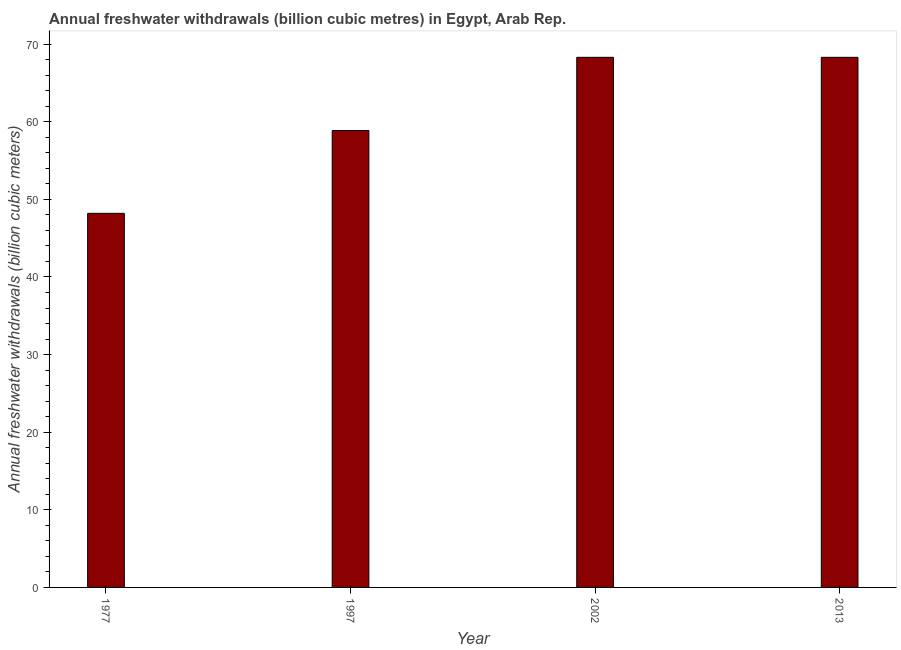Does the graph contain any zero values?
Ensure brevity in your answer.  No. Does the graph contain grids?
Give a very brief answer. No. What is the title of the graph?
Offer a very short reply. Annual freshwater withdrawals (billion cubic metres) in Egypt, Arab Rep. What is the label or title of the Y-axis?
Offer a very short reply. Annual freshwater withdrawals (billion cubic meters). What is the annual freshwater withdrawals in 1997?
Offer a terse response. 58.87. Across all years, what is the maximum annual freshwater withdrawals?
Offer a terse response. 68.3. Across all years, what is the minimum annual freshwater withdrawals?
Provide a short and direct response. 48.2. What is the sum of the annual freshwater withdrawals?
Your response must be concise. 243.67. What is the difference between the annual freshwater withdrawals in 1997 and 2013?
Your response must be concise. -9.43. What is the average annual freshwater withdrawals per year?
Offer a very short reply. 60.92. What is the median annual freshwater withdrawals?
Keep it short and to the point. 63.58. In how many years, is the annual freshwater withdrawals greater than 60 billion cubic meters?
Provide a succinct answer. 2. Do a majority of the years between 1977 and 1997 (inclusive) have annual freshwater withdrawals greater than 4 billion cubic meters?
Provide a succinct answer. Yes. What is the ratio of the annual freshwater withdrawals in 1977 to that in 1997?
Your response must be concise. 0.82. Is the difference between the annual freshwater withdrawals in 1977 and 2002 greater than the difference between any two years?
Keep it short and to the point. Yes. What is the difference between the highest and the lowest annual freshwater withdrawals?
Ensure brevity in your answer.  20.1. Are all the bars in the graph horizontal?
Provide a succinct answer. No. How many years are there in the graph?
Make the answer very short. 4. Are the values on the major ticks of Y-axis written in scientific E-notation?
Ensure brevity in your answer.  No. What is the Annual freshwater withdrawals (billion cubic meters) of 1977?
Your answer should be compact. 48.2. What is the Annual freshwater withdrawals (billion cubic meters) of 1997?
Provide a short and direct response. 58.87. What is the Annual freshwater withdrawals (billion cubic meters) in 2002?
Provide a short and direct response. 68.3. What is the Annual freshwater withdrawals (billion cubic meters) of 2013?
Your response must be concise. 68.3. What is the difference between the Annual freshwater withdrawals (billion cubic meters) in 1977 and 1997?
Keep it short and to the point. -10.67. What is the difference between the Annual freshwater withdrawals (billion cubic meters) in 1977 and 2002?
Offer a very short reply. -20.1. What is the difference between the Annual freshwater withdrawals (billion cubic meters) in 1977 and 2013?
Your answer should be compact. -20.1. What is the difference between the Annual freshwater withdrawals (billion cubic meters) in 1997 and 2002?
Give a very brief answer. -9.43. What is the difference between the Annual freshwater withdrawals (billion cubic meters) in 1997 and 2013?
Provide a short and direct response. -9.43. What is the ratio of the Annual freshwater withdrawals (billion cubic meters) in 1977 to that in 1997?
Your answer should be compact. 0.82. What is the ratio of the Annual freshwater withdrawals (billion cubic meters) in 1977 to that in 2002?
Keep it short and to the point. 0.71. What is the ratio of the Annual freshwater withdrawals (billion cubic meters) in 1977 to that in 2013?
Offer a terse response. 0.71. What is the ratio of the Annual freshwater withdrawals (billion cubic meters) in 1997 to that in 2002?
Your answer should be very brief. 0.86. What is the ratio of the Annual freshwater withdrawals (billion cubic meters) in 1997 to that in 2013?
Offer a terse response. 0.86. 